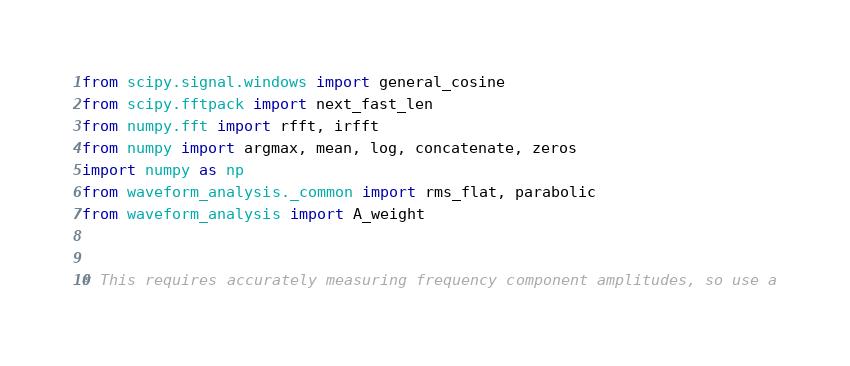Convert code to text. <code><loc_0><loc_0><loc_500><loc_500><_Python_>from scipy.signal.windows import general_cosine
from scipy.fftpack import next_fast_len
from numpy.fft import rfft, irfft
from numpy import argmax, mean, log, concatenate, zeros
import numpy as np
from waveform_analysis._common import rms_flat, parabolic
from waveform_analysis import A_weight


# This requires accurately measuring frequency component amplitudes, so use a</code> 